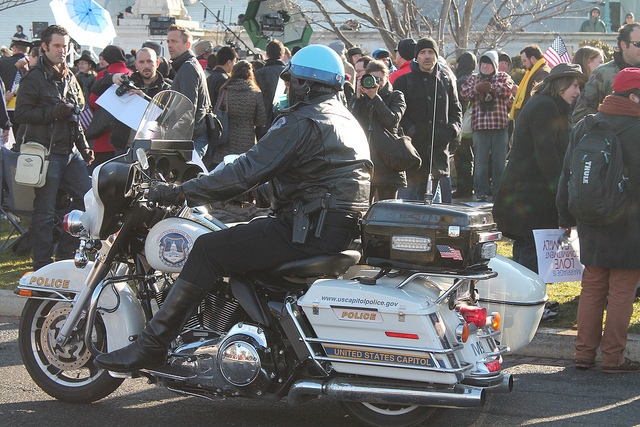<image>What flag do you see? I don't know what flag is seen in the image. It could be the American flag. What flag do you see? I don't know what flag you see. It can be either the USA flag or the American flag. 